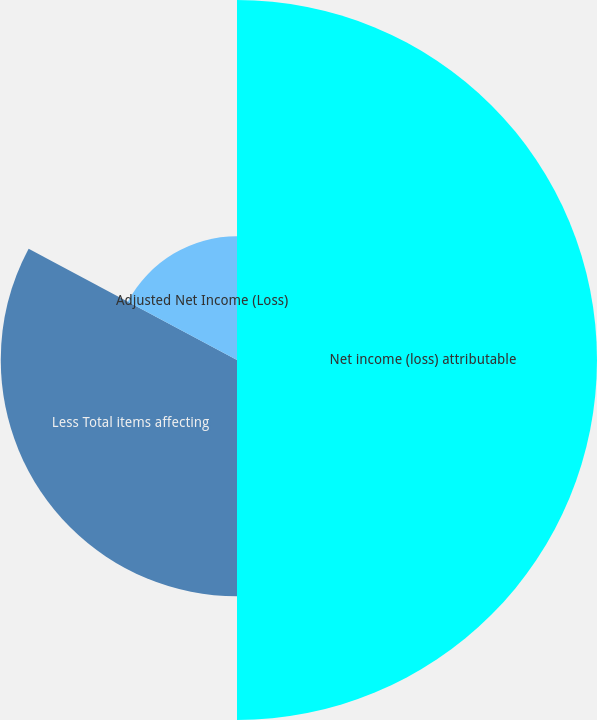Convert chart. <chart><loc_0><loc_0><loc_500><loc_500><pie_chart><fcel>Net income (loss) attributable<fcel>Less Total items affecting<fcel>Adjusted Net Income (Loss)<nl><fcel>50.0%<fcel>32.81%<fcel>17.19%<nl></chart> 